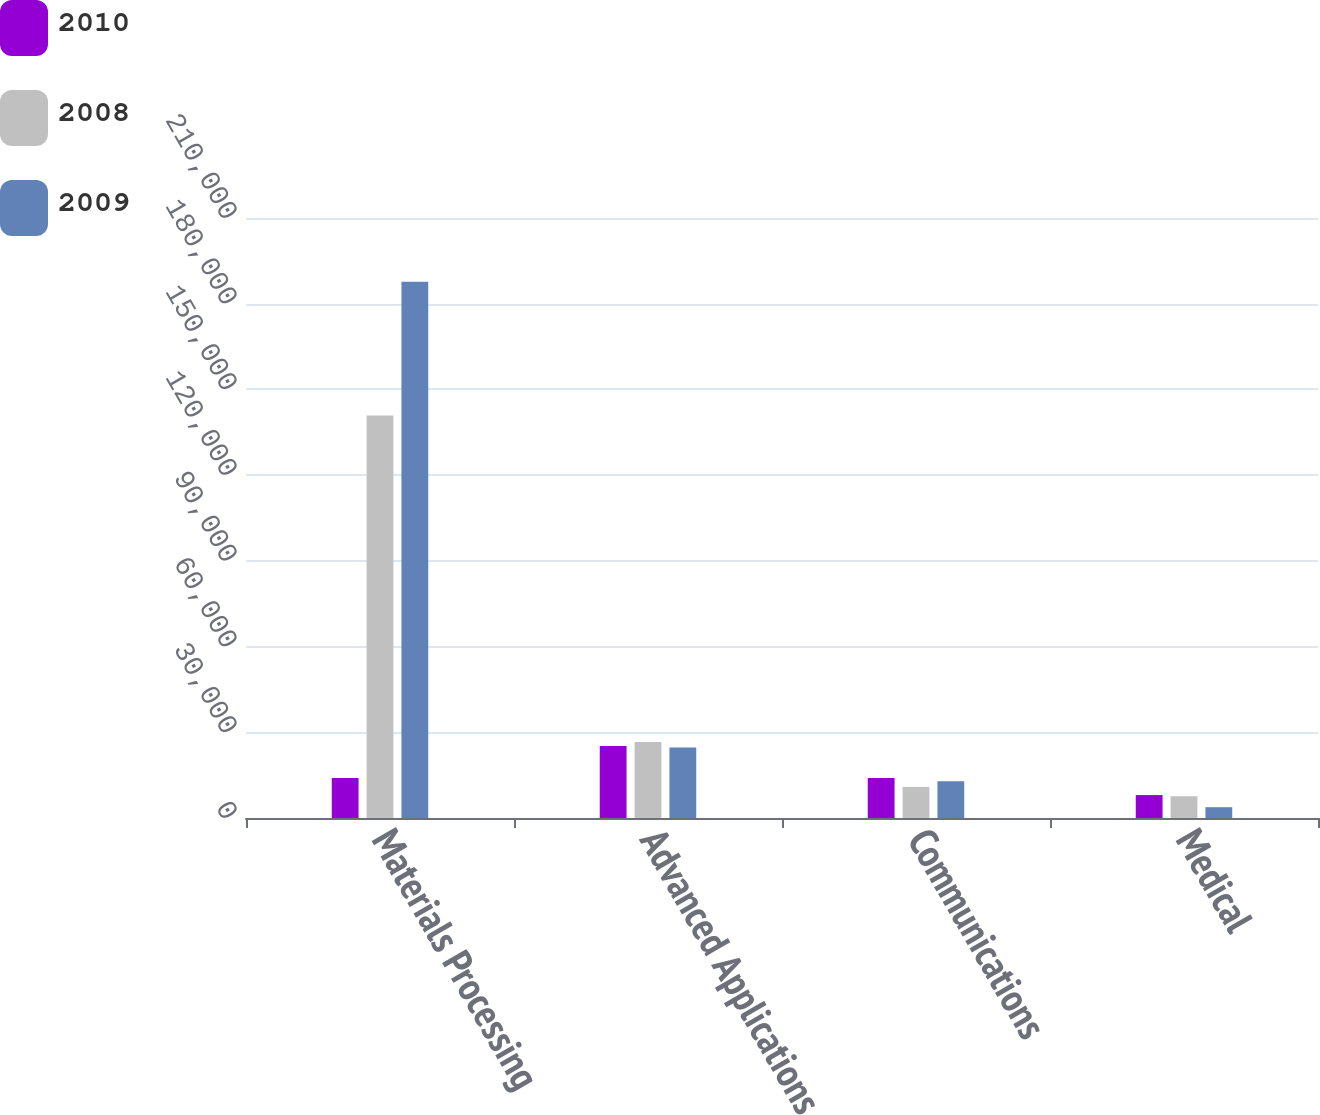Convert chart to OTSL. <chart><loc_0><loc_0><loc_500><loc_500><stacked_bar_chart><ecel><fcel>Materials Processing<fcel>Advanced Applications<fcel>Communications<fcel>Medical<nl><fcel>2010<fcel>14020<fcel>25196<fcel>14020<fcel>8026<nl><fcel>2008<fcel>140864<fcel>26557<fcel>10867<fcel>7606<nl><fcel>2009<fcel>187720<fcel>24670<fcel>12904<fcel>3782<nl></chart> 